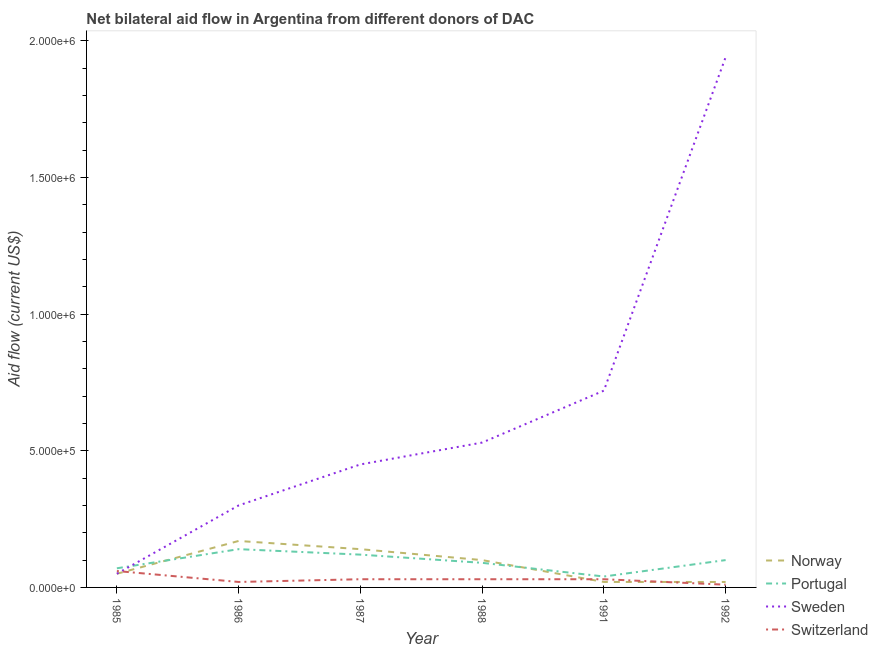Is the number of lines equal to the number of legend labels?
Offer a very short reply. Yes. What is the amount of aid given by switzerland in 1986?
Make the answer very short. 2.00e+04. Across all years, what is the maximum amount of aid given by norway?
Ensure brevity in your answer.  1.70e+05. Across all years, what is the minimum amount of aid given by norway?
Give a very brief answer. 2.00e+04. In which year was the amount of aid given by norway maximum?
Provide a short and direct response. 1986. In which year was the amount of aid given by portugal minimum?
Offer a terse response. 1991. What is the total amount of aid given by portugal in the graph?
Your answer should be very brief. 5.60e+05. What is the difference between the amount of aid given by switzerland in 1985 and that in 1988?
Ensure brevity in your answer.  3.00e+04. What is the average amount of aid given by sweden per year?
Give a very brief answer. 6.65e+05. In the year 1986, what is the difference between the amount of aid given by sweden and amount of aid given by switzerland?
Your answer should be very brief. 2.80e+05. Is the difference between the amount of aid given by sweden in 1987 and 1988 greater than the difference between the amount of aid given by switzerland in 1987 and 1988?
Your answer should be very brief. No. What is the difference between the highest and the second highest amount of aid given by sweden?
Provide a short and direct response. 1.22e+06. What is the difference between the highest and the lowest amount of aid given by switzerland?
Your answer should be very brief. 5.00e+04. Is the sum of the amount of aid given by switzerland in 1988 and 1991 greater than the maximum amount of aid given by portugal across all years?
Your answer should be very brief. No. Is it the case that in every year, the sum of the amount of aid given by switzerland and amount of aid given by portugal is greater than the sum of amount of aid given by sweden and amount of aid given by norway?
Ensure brevity in your answer.  Yes. Does the amount of aid given by norway monotonically increase over the years?
Provide a short and direct response. No. Is the amount of aid given by portugal strictly greater than the amount of aid given by switzerland over the years?
Offer a terse response. Yes. Is the amount of aid given by switzerland strictly less than the amount of aid given by portugal over the years?
Make the answer very short. Yes. How many lines are there?
Your response must be concise. 4. How many years are there in the graph?
Your response must be concise. 6. What is the difference between two consecutive major ticks on the Y-axis?
Provide a succinct answer. 5.00e+05. Are the values on the major ticks of Y-axis written in scientific E-notation?
Provide a succinct answer. Yes. Does the graph contain grids?
Your response must be concise. No. Where does the legend appear in the graph?
Provide a succinct answer. Bottom right. How are the legend labels stacked?
Provide a short and direct response. Vertical. What is the title of the graph?
Your answer should be very brief. Net bilateral aid flow in Argentina from different donors of DAC. What is the label or title of the X-axis?
Offer a very short reply. Year. What is the label or title of the Y-axis?
Keep it short and to the point. Aid flow (current US$). What is the Aid flow (current US$) in Norway in 1985?
Provide a short and direct response. 5.00e+04. What is the Aid flow (current US$) of Norway in 1986?
Offer a terse response. 1.70e+05. What is the Aid flow (current US$) of Portugal in 1986?
Ensure brevity in your answer.  1.40e+05. What is the Aid flow (current US$) of Sweden in 1986?
Offer a terse response. 3.00e+05. What is the Aid flow (current US$) in Portugal in 1987?
Your response must be concise. 1.20e+05. What is the Aid flow (current US$) in Sweden in 1987?
Keep it short and to the point. 4.50e+05. What is the Aid flow (current US$) in Sweden in 1988?
Your answer should be very brief. 5.30e+05. What is the Aid flow (current US$) of Portugal in 1991?
Ensure brevity in your answer.  4.00e+04. What is the Aid flow (current US$) of Sweden in 1991?
Provide a short and direct response. 7.20e+05. What is the Aid flow (current US$) of Portugal in 1992?
Offer a very short reply. 1.00e+05. What is the Aid flow (current US$) of Sweden in 1992?
Provide a short and direct response. 1.94e+06. What is the Aid flow (current US$) in Switzerland in 1992?
Give a very brief answer. 10000. Across all years, what is the maximum Aid flow (current US$) in Portugal?
Make the answer very short. 1.40e+05. Across all years, what is the maximum Aid flow (current US$) in Sweden?
Give a very brief answer. 1.94e+06. Across all years, what is the maximum Aid flow (current US$) of Switzerland?
Make the answer very short. 6.00e+04. Across all years, what is the minimum Aid flow (current US$) of Portugal?
Make the answer very short. 4.00e+04. What is the total Aid flow (current US$) of Norway in the graph?
Make the answer very short. 5.00e+05. What is the total Aid flow (current US$) of Portugal in the graph?
Ensure brevity in your answer.  5.60e+05. What is the total Aid flow (current US$) of Sweden in the graph?
Offer a very short reply. 3.99e+06. What is the total Aid flow (current US$) in Switzerland in the graph?
Make the answer very short. 1.80e+05. What is the difference between the Aid flow (current US$) of Norway in 1985 and that in 1986?
Your answer should be very brief. -1.20e+05. What is the difference between the Aid flow (current US$) in Switzerland in 1985 and that in 1986?
Give a very brief answer. 4.00e+04. What is the difference between the Aid flow (current US$) of Sweden in 1985 and that in 1987?
Your answer should be very brief. -4.00e+05. What is the difference between the Aid flow (current US$) of Portugal in 1985 and that in 1988?
Provide a short and direct response. -2.00e+04. What is the difference between the Aid flow (current US$) of Sweden in 1985 and that in 1988?
Offer a very short reply. -4.80e+05. What is the difference between the Aid flow (current US$) in Switzerland in 1985 and that in 1988?
Ensure brevity in your answer.  3.00e+04. What is the difference between the Aid flow (current US$) in Norway in 1985 and that in 1991?
Keep it short and to the point. 3.00e+04. What is the difference between the Aid flow (current US$) in Sweden in 1985 and that in 1991?
Ensure brevity in your answer.  -6.70e+05. What is the difference between the Aid flow (current US$) in Portugal in 1985 and that in 1992?
Provide a succinct answer. -3.00e+04. What is the difference between the Aid flow (current US$) of Sweden in 1985 and that in 1992?
Keep it short and to the point. -1.89e+06. What is the difference between the Aid flow (current US$) of Sweden in 1986 and that in 1987?
Your answer should be very brief. -1.50e+05. What is the difference between the Aid flow (current US$) in Portugal in 1986 and that in 1988?
Provide a succinct answer. 5.00e+04. What is the difference between the Aid flow (current US$) in Sweden in 1986 and that in 1988?
Offer a terse response. -2.30e+05. What is the difference between the Aid flow (current US$) in Switzerland in 1986 and that in 1988?
Make the answer very short. -10000. What is the difference between the Aid flow (current US$) in Sweden in 1986 and that in 1991?
Your response must be concise. -4.20e+05. What is the difference between the Aid flow (current US$) in Switzerland in 1986 and that in 1991?
Offer a very short reply. -10000. What is the difference between the Aid flow (current US$) of Sweden in 1986 and that in 1992?
Ensure brevity in your answer.  -1.64e+06. What is the difference between the Aid flow (current US$) of Switzerland in 1986 and that in 1992?
Provide a short and direct response. 10000. What is the difference between the Aid flow (current US$) of Norway in 1987 and that in 1991?
Your answer should be very brief. 1.20e+05. What is the difference between the Aid flow (current US$) in Sweden in 1987 and that in 1991?
Offer a terse response. -2.70e+05. What is the difference between the Aid flow (current US$) of Portugal in 1987 and that in 1992?
Your answer should be very brief. 2.00e+04. What is the difference between the Aid flow (current US$) in Sweden in 1987 and that in 1992?
Ensure brevity in your answer.  -1.49e+06. What is the difference between the Aid flow (current US$) in Norway in 1988 and that in 1991?
Offer a terse response. 8.00e+04. What is the difference between the Aid flow (current US$) in Portugal in 1988 and that in 1991?
Provide a short and direct response. 5.00e+04. What is the difference between the Aid flow (current US$) of Sweden in 1988 and that in 1991?
Provide a succinct answer. -1.90e+05. What is the difference between the Aid flow (current US$) in Switzerland in 1988 and that in 1991?
Ensure brevity in your answer.  0. What is the difference between the Aid flow (current US$) of Sweden in 1988 and that in 1992?
Make the answer very short. -1.41e+06. What is the difference between the Aid flow (current US$) in Switzerland in 1988 and that in 1992?
Provide a short and direct response. 2.00e+04. What is the difference between the Aid flow (current US$) in Portugal in 1991 and that in 1992?
Your response must be concise. -6.00e+04. What is the difference between the Aid flow (current US$) in Sweden in 1991 and that in 1992?
Provide a short and direct response. -1.22e+06. What is the difference between the Aid flow (current US$) of Norway in 1985 and the Aid flow (current US$) of Portugal in 1986?
Offer a very short reply. -9.00e+04. What is the difference between the Aid flow (current US$) of Norway in 1985 and the Aid flow (current US$) of Sweden in 1986?
Your answer should be compact. -2.50e+05. What is the difference between the Aid flow (current US$) of Portugal in 1985 and the Aid flow (current US$) of Sweden in 1986?
Keep it short and to the point. -2.30e+05. What is the difference between the Aid flow (current US$) of Norway in 1985 and the Aid flow (current US$) of Sweden in 1987?
Make the answer very short. -4.00e+05. What is the difference between the Aid flow (current US$) in Norway in 1985 and the Aid flow (current US$) in Switzerland in 1987?
Give a very brief answer. 2.00e+04. What is the difference between the Aid flow (current US$) in Portugal in 1985 and the Aid flow (current US$) in Sweden in 1987?
Give a very brief answer. -3.80e+05. What is the difference between the Aid flow (current US$) of Norway in 1985 and the Aid flow (current US$) of Sweden in 1988?
Provide a succinct answer. -4.80e+05. What is the difference between the Aid flow (current US$) of Portugal in 1985 and the Aid flow (current US$) of Sweden in 1988?
Give a very brief answer. -4.60e+05. What is the difference between the Aid flow (current US$) of Portugal in 1985 and the Aid flow (current US$) of Switzerland in 1988?
Keep it short and to the point. 4.00e+04. What is the difference between the Aid flow (current US$) in Norway in 1985 and the Aid flow (current US$) in Sweden in 1991?
Keep it short and to the point. -6.70e+05. What is the difference between the Aid flow (current US$) of Norway in 1985 and the Aid flow (current US$) of Switzerland in 1991?
Provide a short and direct response. 2.00e+04. What is the difference between the Aid flow (current US$) in Portugal in 1985 and the Aid flow (current US$) in Sweden in 1991?
Your response must be concise. -6.50e+05. What is the difference between the Aid flow (current US$) of Norway in 1985 and the Aid flow (current US$) of Sweden in 1992?
Provide a short and direct response. -1.89e+06. What is the difference between the Aid flow (current US$) of Portugal in 1985 and the Aid flow (current US$) of Sweden in 1992?
Offer a terse response. -1.87e+06. What is the difference between the Aid flow (current US$) of Norway in 1986 and the Aid flow (current US$) of Portugal in 1987?
Provide a short and direct response. 5.00e+04. What is the difference between the Aid flow (current US$) of Norway in 1986 and the Aid flow (current US$) of Sweden in 1987?
Offer a terse response. -2.80e+05. What is the difference between the Aid flow (current US$) of Norway in 1986 and the Aid flow (current US$) of Switzerland in 1987?
Your response must be concise. 1.40e+05. What is the difference between the Aid flow (current US$) in Portugal in 1986 and the Aid flow (current US$) in Sweden in 1987?
Your answer should be very brief. -3.10e+05. What is the difference between the Aid flow (current US$) in Sweden in 1986 and the Aid flow (current US$) in Switzerland in 1987?
Keep it short and to the point. 2.70e+05. What is the difference between the Aid flow (current US$) of Norway in 1986 and the Aid flow (current US$) of Sweden in 1988?
Ensure brevity in your answer.  -3.60e+05. What is the difference between the Aid flow (current US$) in Norway in 1986 and the Aid flow (current US$) in Switzerland in 1988?
Offer a terse response. 1.40e+05. What is the difference between the Aid flow (current US$) of Portugal in 1986 and the Aid flow (current US$) of Sweden in 1988?
Keep it short and to the point. -3.90e+05. What is the difference between the Aid flow (current US$) of Norway in 1986 and the Aid flow (current US$) of Portugal in 1991?
Provide a short and direct response. 1.30e+05. What is the difference between the Aid flow (current US$) in Norway in 1986 and the Aid flow (current US$) in Sweden in 1991?
Offer a terse response. -5.50e+05. What is the difference between the Aid flow (current US$) in Norway in 1986 and the Aid flow (current US$) in Switzerland in 1991?
Offer a very short reply. 1.40e+05. What is the difference between the Aid flow (current US$) in Portugal in 1986 and the Aid flow (current US$) in Sweden in 1991?
Your answer should be compact. -5.80e+05. What is the difference between the Aid flow (current US$) in Portugal in 1986 and the Aid flow (current US$) in Switzerland in 1991?
Keep it short and to the point. 1.10e+05. What is the difference between the Aid flow (current US$) in Norway in 1986 and the Aid flow (current US$) in Sweden in 1992?
Offer a terse response. -1.77e+06. What is the difference between the Aid flow (current US$) in Portugal in 1986 and the Aid flow (current US$) in Sweden in 1992?
Your answer should be compact. -1.80e+06. What is the difference between the Aid flow (current US$) of Sweden in 1986 and the Aid flow (current US$) of Switzerland in 1992?
Offer a very short reply. 2.90e+05. What is the difference between the Aid flow (current US$) in Norway in 1987 and the Aid flow (current US$) in Sweden in 1988?
Make the answer very short. -3.90e+05. What is the difference between the Aid flow (current US$) in Norway in 1987 and the Aid flow (current US$) in Switzerland in 1988?
Your answer should be compact. 1.10e+05. What is the difference between the Aid flow (current US$) of Portugal in 1987 and the Aid flow (current US$) of Sweden in 1988?
Offer a terse response. -4.10e+05. What is the difference between the Aid flow (current US$) of Portugal in 1987 and the Aid flow (current US$) of Switzerland in 1988?
Your answer should be very brief. 9.00e+04. What is the difference between the Aid flow (current US$) in Sweden in 1987 and the Aid flow (current US$) in Switzerland in 1988?
Your response must be concise. 4.20e+05. What is the difference between the Aid flow (current US$) in Norway in 1987 and the Aid flow (current US$) in Portugal in 1991?
Your answer should be very brief. 1.00e+05. What is the difference between the Aid flow (current US$) of Norway in 1987 and the Aid flow (current US$) of Sweden in 1991?
Your answer should be compact. -5.80e+05. What is the difference between the Aid flow (current US$) in Norway in 1987 and the Aid flow (current US$) in Switzerland in 1991?
Offer a very short reply. 1.10e+05. What is the difference between the Aid flow (current US$) in Portugal in 1987 and the Aid flow (current US$) in Sweden in 1991?
Your answer should be compact. -6.00e+05. What is the difference between the Aid flow (current US$) of Norway in 1987 and the Aid flow (current US$) of Sweden in 1992?
Provide a short and direct response. -1.80e+06. What is the difference between the Aid flow (current US$) of Portugal in 1987 and the Aid flow (current US$) of Sweden in 1992?
Make the answer very short. -1.82e+06. What is the difference between the Aid flow (current US$) of Portugal in 1987 and the Aid flow (current US$) of Switzerland in 1992?
Give a very brief answer. 1.10e+05. What is the difference between the Aid flow (current US$) in Norway in 1988 and the Aid flow (current US$) in Portugal in 1991?
Ensure brevity in your answer.  6.00e+04. What is the difference between the Aid flow (current US$) in Norway in 1988 and the Aid flow (current US$) in Sweden in 1991?
Keep it short and to the point. -6.20e+05. What is the difference between the Aid flow (current US$) in Portugal in 1988 and the Aid flow (current US$) in Sweden in 1991?
Your answer should be compact. -6.30e+05. What is the difference between the Aid flow (current US$) of Norway in 1988 and the Aid flow (current US$) of Portugal in 1992?
Offer a terse response. 0. What is the difference between the Aid flow (current US$) of Norway in 1988 and the Aid flow (current US$) of Sweden in 1992?
Ensure brevity in your answer.  -1.84e+06. What is the difference between the Aid flow (current US$) in Norway in 1988 and the Aid flow (current US$) in Switzerland in 1992?
Your answer should be compact. 9.00e+04. What is the difference between the Aid flow (current US$) in Portugal in 1988 and the Aid flow (current US$) in Sweden in 1992?
Offer a terse response. -1.85e+06. What is the difference between the Aid flow (current US$) in Sweden in 1988 and the Aid flow (current US$) in Switzerland in 1992?
Your answer should be very brief. 5.20e+05. What is the difference between the Aid flow (current US$) of Norway in 1991 and the Aid flow (current US$) of Sweden in 1992?
Keep it short and to the point. -1.92e+06. What is the difference between the Aid flow (current US$) in Norway in 1991 and the Aid flow (current US$) in Switzerland in 1992?
Your answer should be compact. 10000. What is the difference between the Aid flow (current US$) in Portugal in 1991 and the Aid flow (current US$) in Sweden in 1992?
Ensure brevity in your answer.  -1.90e+06. What is the difference between the Aid flow (current US$) of Portugal in 1991 and the Aid flow (current US$) of Switzerland in 1992?
Offer a terse response. 3.00e+04. What is the difference between the Aid flow (current US$) in Sweden in 1991 and the Aid flow (current US$) in Switzerland in 1992?
Your answer should be very brief. 7.10e+05. What is the average Aid flow (current US$) in Norway per year?
Make the answer very short. 8.33e+04. What is the average Aid flow (current US$) in Portugal per year?
Offer a terse response. 9.33e+04. What is the average Aid flow (current US$) in Sweden per year?
Your answer should be very brief. 6.65e+05. What is the average Aid flow (current US$) of Switzerland per year?
Give a very brief answer. 3.00e+04. In the year 1985, what is the difference between the Aid flow (current US$) of Norway and Aid flow (current US$) of Portugal?
Give a very brief answer. -2.00e+04. In the year 1985, what is the difference between the Aid flow (current US$) of Norway and Aid flow (current US$) of Sweden?
Give a very brief answer. 0. In the year 1985, what is the difference between the Aid flow (current US$) in Portugal and Aid flow (current US$) in Switzerland?
Your answer should be compact. 10000. In the year 1986, what is the difference between the Aid flow (current US$) in Norway and Aid flow (current US$) in Portugal?
Your response must be concise. 3.00e+04. In the year 1986, what is the difference between the Aid flow (current US$) in Portugal and Aid flow (current US$) in Sweden?
Keep it short and to the point. -1.60e+05. In the year 1986, what is the difference between the Aid flow (current US$) in Portugal and Aid flow (current US$) in Switzerland?
Ensure brevity in your answer.  1.20e+05. In the year 1986, what is the difference between the Aid flow (current US$) of Sweden and Aid flow (current US$) of Switzerland?
Provide a succinct answer. 2.80e+05. In the year 1987, what is the difference between the Aid flow (current US$) of Norway and Aid flow (current US$) of Sweden?
Make the answer very short. -3.10e+05. In the year 1987, what is the difference between the Aid flow (current US$) in Norway and Aid flow (current US$) in Switzerland?
Give a very brief answer. 1.10e+05. In the year 1987, what is the difference between the Aid flow (current US$) in Portugal and Aid flow (current US$) in Sweden?
Your answer should be very brief. -3.30e+05. In the year 1987, what is the difference between the Aid flow (current US$) of Sweden and Aid flow (current US$) of Switzerland?
Offer a terse response. 4.20e+05. In the year 1988, what is the difference between the Aid flow (current US$) of Norway and Aid flow (current US$) of Sweden?
Ensure brevity in your answer.  -4.30e+05. In the year 1988, what is the difference between the Aid flow (current US$) in Portugal and Aid flow (current US$) in Sweden?
Your answer should be compact. -4.40e+05. In the year 1988, what is the difference between the Aid flow (current US$) of Sweden and Aid flow (current US$) of Switzerland?
Keep it short and to the point. 5.00e+05. In the year 1991, what is the difference between the Aid flow (current US$) of Norway and Aid flow (current US$) of Portugal?
Give a very brief answer. -2.00e+04. In the year 1991, what is the difference between the Aid flow (current US$) of Norway and Aid flow (current US$) of Sweden?
Your answer should be very brief. -7.00e+05. In the year 1991, what is the difference between the Aid flow (current US$) in Norway and Aid flow (current US$) in Switzerland?
Make the answer very short. -10000. In the year 1991, what is the difference between the Aid flow (current US$) in Portugal and Aid flow (current US$) in Sweden?
Keep it short and to the point. -6.80e+05. In the year 1991, what is the difference between the Aid flow (current US$) of Portugal and Aid flow (current US$) of Switzerland?
Give a very brief answer. 10000. In the year 1991, what is the difference between the Aid flow (current US$) in Sweden and Aid flow (current US$) in Switzerland?
Keep it short and to the point. 6.90e+05. In the year 1992, what is the difference between the Aid flow (current US$) in Norway and Aid flow (current US$) in Portugal?
Your response must be concise. -8.00e+04. In the year 1992, what is the difference between the Aid flow (current US$) in Norway and Aid flow (current US$) in Sweden?
Your response must be concise. -1.92e+06. In the year 1992, what is the difference between the Aid flow (current US$) in Norway and Aid flow (current US$) in Switzerland?
Your response must be concise. 10000. In the year 1992, what is the difference between the Aid flow (current US$) in Portugal and Aid flow (current US$) in Sweden?
Ensure brevity in your answer.  -1.84e+06. In the year 1992, what is the difference between the Aid flow (current US$) of Sweden and Aid flow (current US$) of Switzerland?
Your response must be concise. 1.93e+06. What is the ratio of the Aid flow (current US$) of Norway in 1985 to that in 1986?
Ensure brevity in your answer.  0.29. What is the ratio of the Aid flow (current US$) in Portugal in 1985 to that in 1986?
Your response must be concise. 0.5. What is the ratio of the Aid flow (current US$) of Sweden in 1985 to that in 1986?
Your response must be concise. 0.17. What is the ratio of the Aid flow (current US$) in Switzerland in 1985 to that in 1986?
Keep it short and to the point. 3. What is the ratio of the Aid flow (current US$) of Norway in 1985 to that in 1987?
Give a very brief answer. 0.36. What is the ratio of the Aid flow (current US$) in Portugal in 1985 to that in 1987?
Offer a very short reply. 0.58. What is the ratio of the Aid flow (current US$) in Sweden in 1985 to that in 1987?
Offer a terse response. 0.11. What is the ratio of the Aid flow (current US$) in Switzerland in 1985 to that in 1987?
Your answer should be very brief. 2. What is the ratio of the Aid flow (current US$) in Portugal in 1985 to that in 1988?
Your response must be concise. 0.78. What is the ratio of the Aid flow (current US$) of Sweden in 1985 to that in 1988?
Provide a short and direct response. 0.09. What is the ratio of the Aid flow (current US$) of Norway in 1985 to that in 1991?
Offer a terse response. 2.5. What is the ratio of the Aid flow (current US$) in Portugal in 1985 to that in 1991?
Keep it short and to the point. 1.75. What is the ratio of the Aid flow (current US$) in Sweden in 1985 to that in 1991?
Your answer should be very brief. 0.07. What is the ratio of the Aid flow (current US$) in Norway in 1985 to that in 1992?
Your answer should be compact. 2.5. What is the ratio of the Aid flow (current US$) in Portugal in 1985 to that in 1992?
Give a very brief answer. 0.7. What is the ratio of the Aid flow (current US$) in Sweden in 1985 to that in 1992?
Keep it short and to the point. 0.03. What is the ratio of the Aid flow (current US$) in Switzerland in 1985 to that in 1992?
Ensure brevity in your answer.  6. What is the ratio of the Aid flow (current US$) of Norway in 1986 to that in 1987?
Make the answer very short. 1.21. What is the ratio of the Aid flow (current US$) of Sweden in 1986 to that in 1987?
Your answer should be very brief. 0.67. What is the ratio of the Aid flow (current US$) of Switzerland in 1986 to that in 1987?
Keep it short and to the point. 0.67. What is the ratio of the Aid flow (current US$) in Portugal in 1986 to that in 1988?
Your answer should be compact. 1.56. What is the ratio of the Aid flow (current US$) of Sweden in 1986 to that in 1988?
Provide a succinct answer. 0.57. What is the ratio of the Aid flow (current US$) in Switzerland in 1986 to that in 1988?
Offer a terse response. 0.67. What is the ratio of the Aid flow (current US$) in Sweden in 1986 to that in 1991?
Offer a very short reply. 0.42. What is the ratio of the Aid flow (current US$) in Norway in 1986 to that in 1992?
Offer a terse response. 8.5. What is the ratio of the Aid flow (current US$) of Portugal in 1986 to that in 1992?
Offer a very short reply. 1.4. What is the ratio of the Aid flow (current US$) in Sweden in 1986 to that in 1992?
Keep it short and to the point. 0.15. What is the ratio of the Aid flow (current US$) in Sweden in 1987 to that in 1988?
Your response must be concise. 0.85. What is the ratio of the Aid flow (current US$) of Switzerland in 1987 to that in 1988?
Provide a short and direct response. 1. What is the ratio of the Aid flow (current US$) in Sweden in 1987 to that in 1991?
Your response must be concise. 0.62. What is the ratio of the Aid flow (current US$) in Switzerland in 1987 to that in 1991?
Give a very brief answer. 1. What is the ratio of the Aid flow (current US$) of Sweden in 1987 to that in 1992?
Offer a very short reply. 0.23. What is the ratio of the Aid flow (current US$) in Portugal in 1988 to that in 1991?
Your response must be concise. 2.25. What is the ratio of the Aid flow (current US$) of Sweden in 1988 to that in 1991?
Provide a short and direct response. 0.74. What is the ratio of the Aid flow (current US$) of Norway in 1988 to that in 1992?
Provide a short and direct response. 5. What is the ratio of the Aid flow (current US$) of Sweden in 1988 to that in 1992?
Offer a very short reply. 0.27. What is the ratio of the Aid flow (current US$) of Switzerland in 1988 to that in 1992?
Your response must be concise. 3. What is the ratio of the Aid flow (current US$) of Sweden in 1991 to that in 1992?
Ensure brevity in your answer.  0.37. What is the difference between the highest and the second highest Aid flow (current US$) of Sweden?
Provide a short and direct response. 1.22e+06. What is the difference between the highest and the lowest Aid flow (current US$) of Norway?
Provide a short and direct response. 1.50e+05. What is the difference between the highest and the lowest Aid flow (current US$) of Portugal?
Your response must be concise. 1.00e+05. What is the difference between the highest and the lowest Aid flow (current US$) in Sweden?
Give a very brief answer. 1.89e+06. 